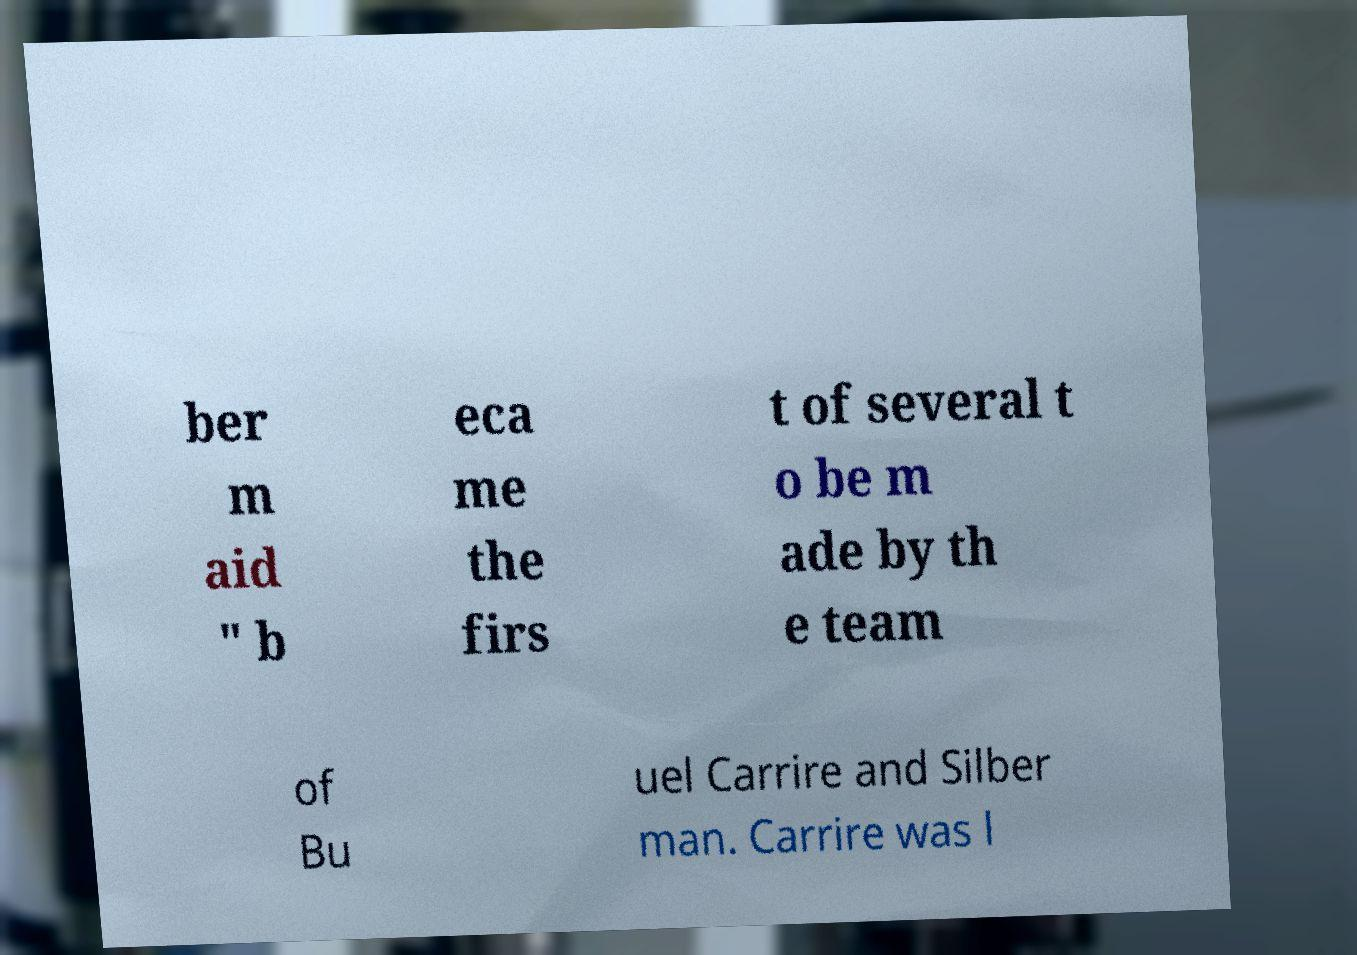Could you extract and type out the text from this image? ber m aid " b eca me the firs t of several t o be m ade by th e team of Bu uel Carrire and Silber man. Carrire was l 